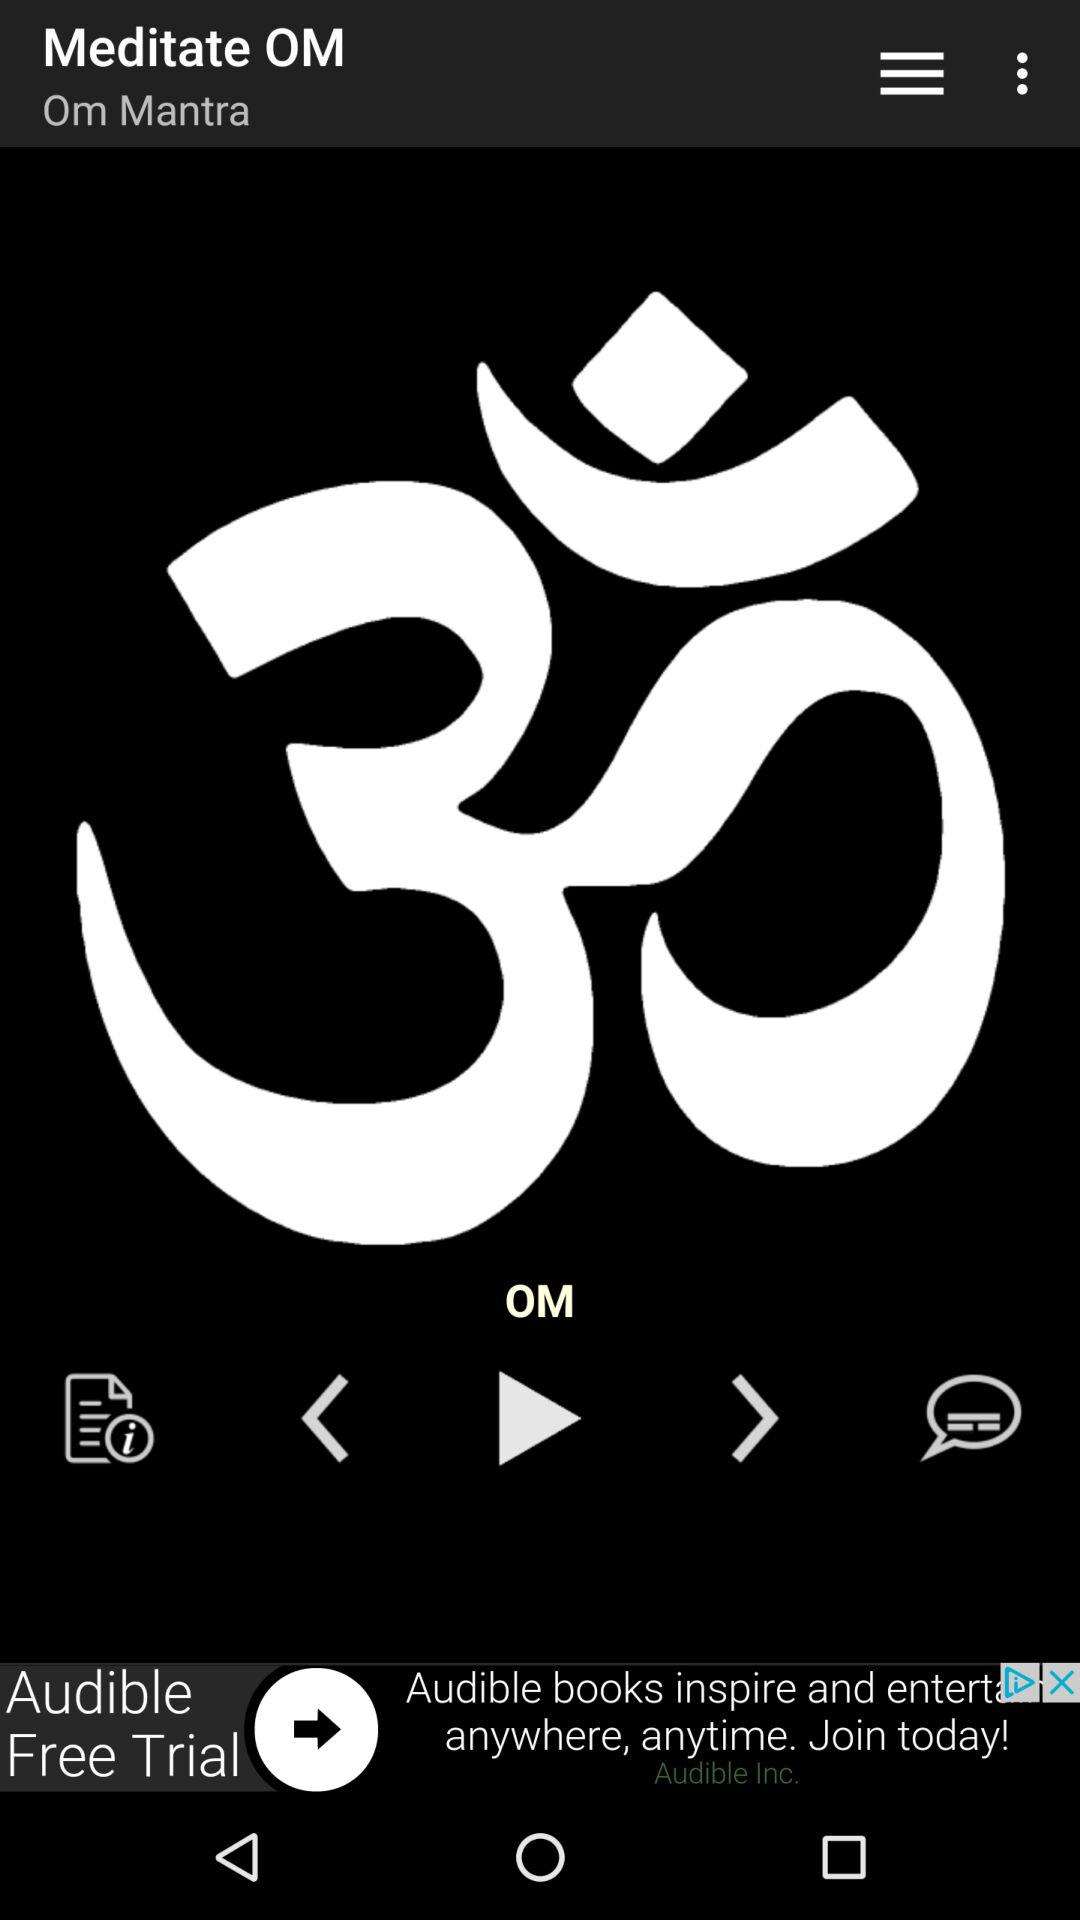How long is the duration of the meditation?
When the provided information is insufficient, respond with <no answer>. <no answer> 